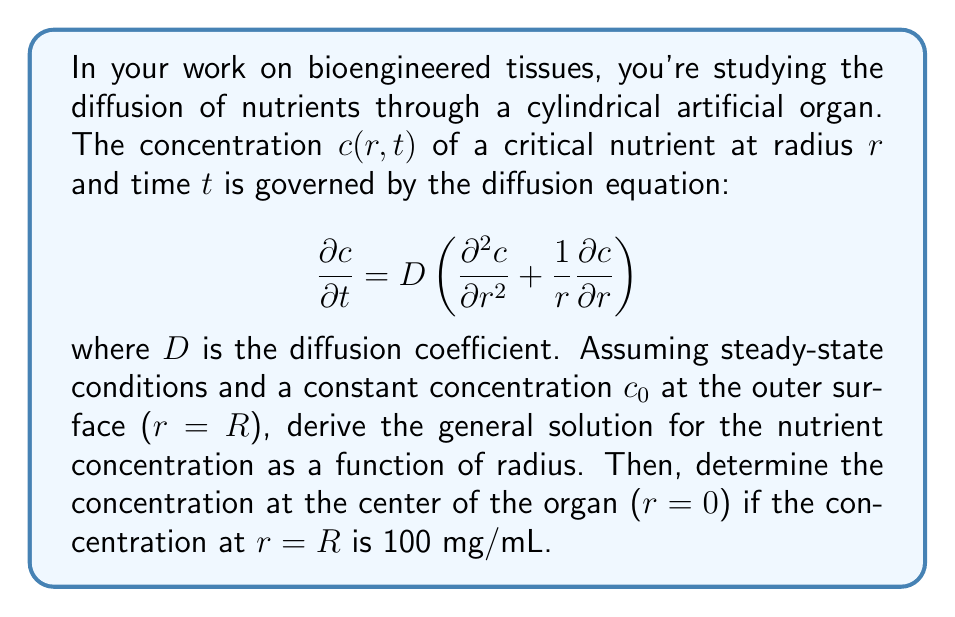Can you answer this question? Let's approach this problem step-by-step:

1) In steady-state conditions, the concentration doesn't change with time, so $\frac{\partial c}{\partial t} = 0$. Our equation becomes:

   $$0 = D \left(\frac{d^2 c}{dr^2} + \frac{1}{r}\frac{dc}{dr}\right)$$

2) Dividing both sides by $D$ (assuming $D \neq 0$):

   $$\frac{d^2 c}{dr^2} + \frac{1}{r}\frac{dc}{dr} = 0$$

3) This is a second-order linear ordinary differential equation. To solve it, let's make a substitution: $u = \frac{dc}{dr}$. Then $\frac{d^2c}{dr^2} = \frac{du}{dr}$. Our equation becomes:

   $$\frac{du}{dr} + \frac{1}{r}u = 0$$

4) This is a first-order linear ODE. We can solve it by separation of variables:

   $$\frac{du}{u} = -\frac{dr}{r}$$

5) Integrating both sides:

   $$\ln|u| = -\ln|r| + \ln|K_1|$$

   where $K_1$ is a constant of integration.

6) Exponentiating both sides:

   $$u = \frac{K_1}{r}$$

7) Recall that $u = \frac{dc}{dr}$, so:

   $$\frac{dc}{dr} = \frac{K_1}{r}$$

8) Integrating again:

   $$c = K_1 \ln|r| + K_2$$

   where $K_2$ is another constant of integration.

9) This is our general solution. To find $K_1$ and $K_2$, we need boundary conditions. We're given that $c(R) = c_0 = 100$ mg/mL. We also know that at $r=0$, the concentration must be finite, which means $K_1$ must be zero (otherwise, $\ln|r|$ would approach negative infinity as $r$ approaches zero).

10) With $K_1 = 0$, our solution simplifies to $c = K_2 = c_0 = 100$ mg/mL.

Therefore, in this steady-state scenario with the given boundary condition, the concentration is constant throughout the organ, including at the center.
Answer: The concentration at the center of the organ ($r=0$) is 100 mg/mL. 